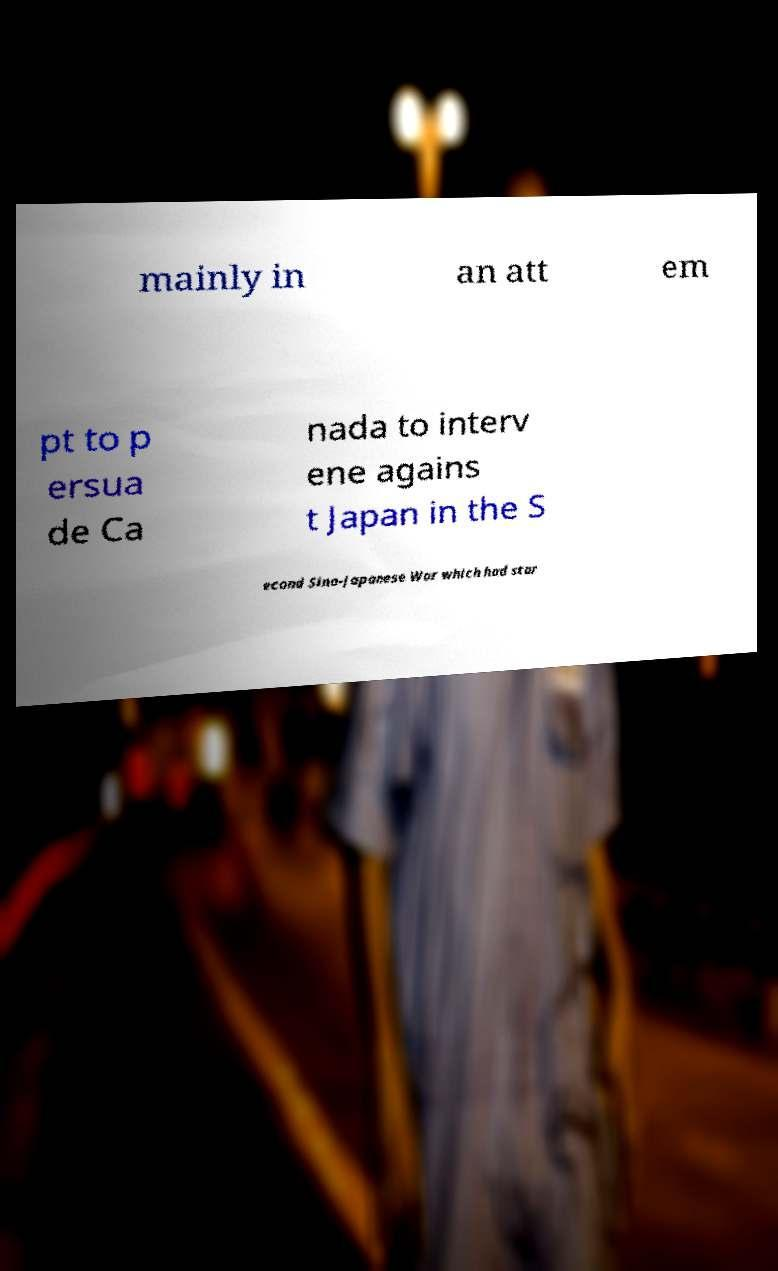I need the written content from this picture converted into text. Can you do that? mainly in an att em pt to p ersua de Ca nada to interv ene agains t Japan in the S econd Sino-Japanese War which had star 